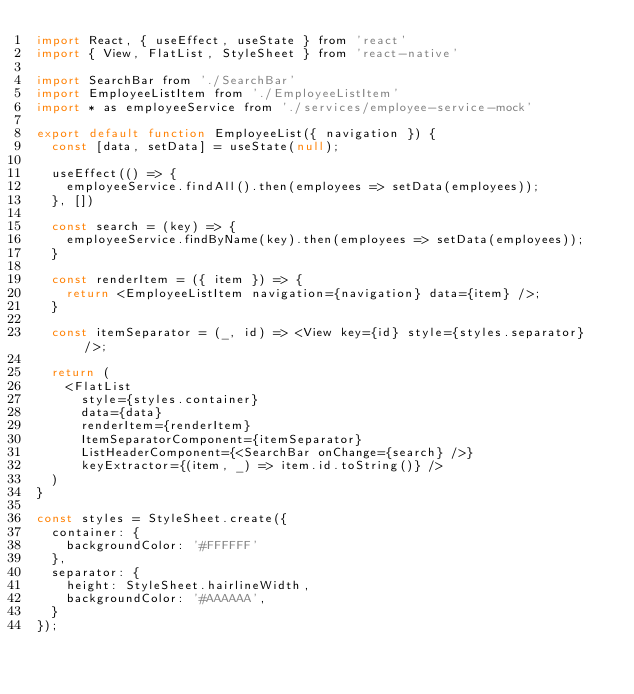<code> <loc_0><loc_0><loc_500><loc_500><_JavaScript_>import React, { useEffect, useState } from 'react'
import { View, FlatList, StyleSheet } from 'react-native'

import SearchBar from './SearchBar'
import EmployeeListItem from './EmployeeListItem'
import * as employeeService from './services/employee-service-mock'

export default function EmployeeList({ navigation }) {
  const [data, setData] = useState(null);

  useEffect(() => {
    employeeService.findAll().then(employees => setData(employees));
  }, [])

  const search = (key) => {
    employeeService.findByName(key).then(employees => setData(employees));
  }

  const renderItem = ({ item }) => {
    return <EmployeeListItem navigation={navigation} data={item} />;
  }

  const itemSeparator = (_, id) => <View key={id} style={styles.separator} />;

  return (
    <FlatList
      style={styles.container}
      data={data}
      renderItem={renderItem}
      ItemSeparatorComponent={itemSeparator}
      ListHeaderComponent={<SearchBar onChange={search} />}
      keyExtractor={(item, _) => item.id.toString()} />
  )
}

const styles = StyleSheet.create({
  container: {
    backgroundColor: '#FFFFFF'
  },
  separator: {
    height: StyleSheet.hairlineWidth,
    backgroundColor: '#AAAAAA',
  }
});
</code> 